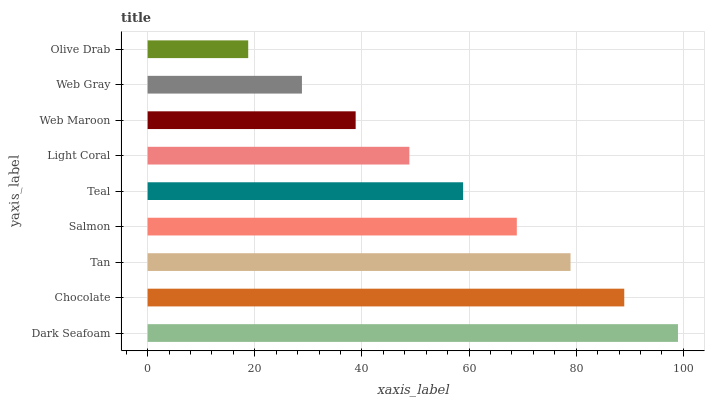Is Olive Drab the minimum?
Answer yes or no. Yes. Is Dark Seafoam the maximum?
Answer yes or no. Yes. Is Chocolate the minimum?
Answer yes or no. No. Is Chocolate the maximum?
Answer yes or no. No. Is Dark Seafoam greater than Chocolate?
Answer yes or no. Yes. Is Chocolate less than Dark Seafoam?
Answer yes or no. Yes. Is Chocolate greater than Dark Seafoam?
Answer yes or no. No. Is Dark Seafoam less than Chocolate?
Answer yes or no. No. Is Teal the high median?
Answer yes or no. Yes. Is Teal the low median?
Answer yes or no. Yes. Is Olive Drab the high median?
Answer yes or no. No. Is Tan the low median?
Answer yes or no. No. 